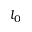Convert formula to latex. <formula><loc_0><loc_0><loc_500><loc_500>l _ { 0 }</formula> 